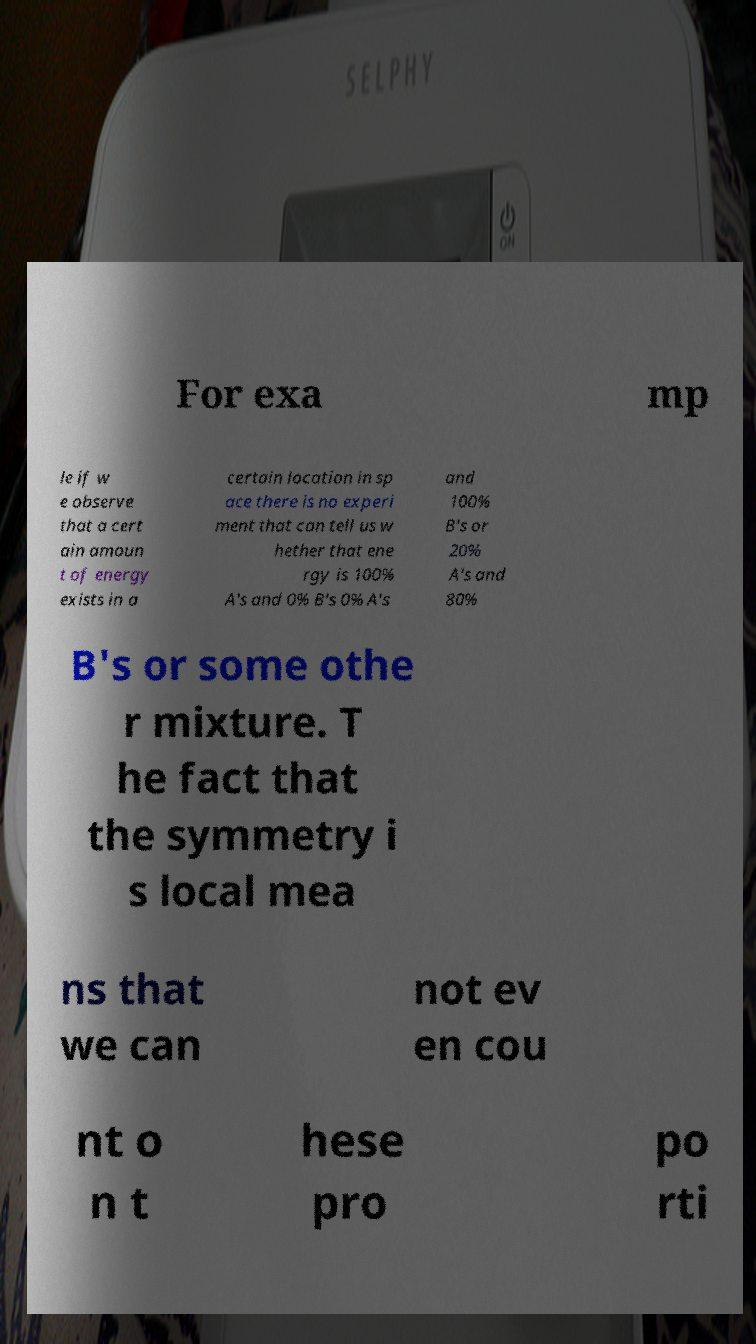Please identify and transcribe the text found in this image. For exa mp le if w e observe that a cert ain amoun t of energy exists in a certain location in sp ace there is no experi ment that can tell us w hether that ene rgy is 100% A's and 0% B's 0% A's and 100% B's or 20% A's and 80% B's or some othe r mixture. T he fact that the symmetry i s local mea ns that we can not ev en cou nt o n t hese pro po rti 